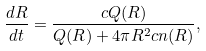<formula> <loc_0><loc_0><loc_500><loc_500>\frac { d R } { d t } = \frac { c Q ( R ) } { Q ( R ) + 4 \pi R ^ { 2 } c n ( R ) } ,</formula> 